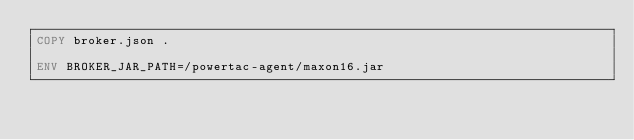Convert code to text. <code><loc_0><loc_0><loc_500><loc_500><_Dockerfile_>COPY broker.json .

ENV BROKER_JAR_PATH=/powertac-agent/maxon16.jar</code> 